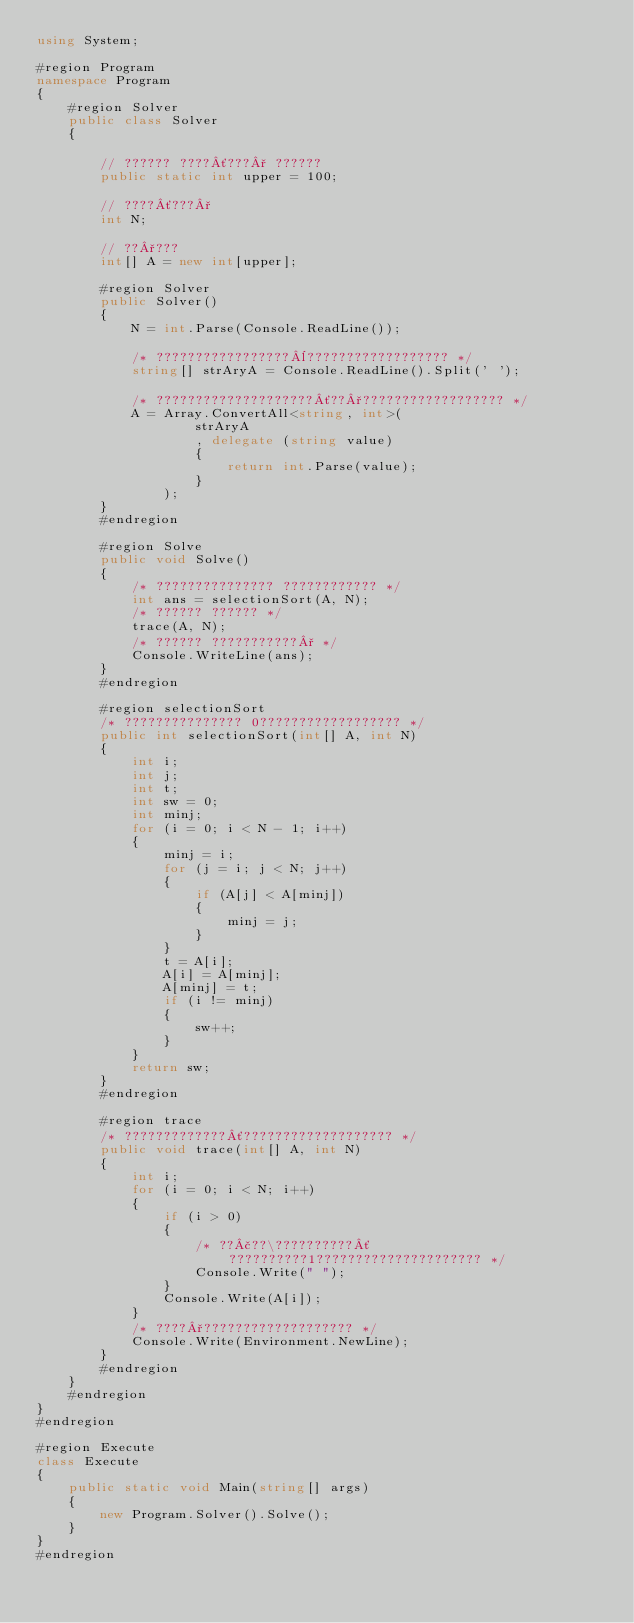<code> <loc_0><loc_0><loc_500><loc_500><_C#_>using System;

#region Program
namespace Program
{
    #region Solver
    public class Solver
    {

        // ?????? ????´???° ??????
        public static int upper = 100;

        // ????´???°
        int N;

        // ??°???
        int[] A = new int[upper];

        #region Solver
        public Solver()
        {
            N = int.Parse(Console.ReadLine());

            /* ?????????????????¨?????????????????? */
            string[] strAryA = Console.ReadLine().Split(' ');

            /* ????????????????????´??°?????????????????? */
            A = Array.ConvertAll<string, int>(
                    strAryA
                    , delegate (string value)
                    {
                        return int.Parse(value);
                    }
                );
        }
        #endregion

        #region Solve
        public void Solve()
        {
            /* ??????????????? ???????????? */
            int ans = selectionSort(A, N);
            /* ?????? ?????? */
            trace(A, N);
            /* ?????? ???????????° */
            Console.WriteLine(ans);
        }
        #endregion

        #region selectionSort
        /* ??????????????? 0?????????????????? */
        public int selectionSort(int[] A, int N)
        {
            int i;
            int j;
            int t;
            int sw = 0;
            int minj;
            for (i = 0; i < N - 1; i++)
            {
                minj = i;
                for (j = i; j < N; j++)
                {
                    if (A[j] < A[minj])
                    {
                        minj = j;
                    }
                }
                t = A[i];
                A[i] = A[minj];
                A[minj] = t;
                if (i != minj)
                {
                    sw++;
                }
            }
            return sw;
        }
        #endregion

        #region trace
        /* ?????????????´??????????????????? */
        public void trace(int[] A, int N)
        {
            int i;
            for (i = 0; i < N; i++)
            {
                if (i > 0)
                {
                    /* ??£??\??????????´??????????1????????????????????? */
                    Console.Write(" ");
                }
                Console.Write(A[i]);
            }
            /* ????°??????????????????? */
            Console.Write(Environment.NewLine);
        }
        #endregion
    }
    #endregion
}
#endregion

#region Execute
class Execute
{
    public static void Main(string[] args)
    {
        new Program.Solver().Solve();
    }
}
#endregion</code> 